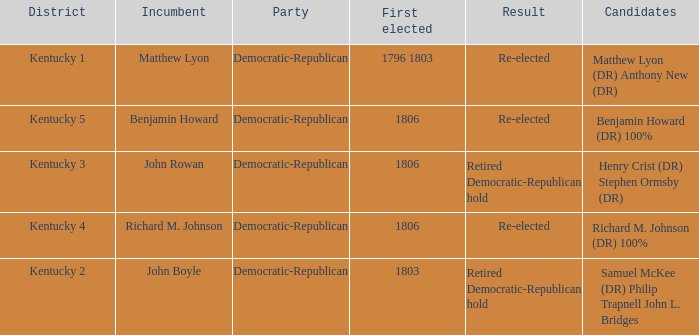Name the incumbent for  matthew lyon (dr) anthony new (dr) Matthew Lyon. 